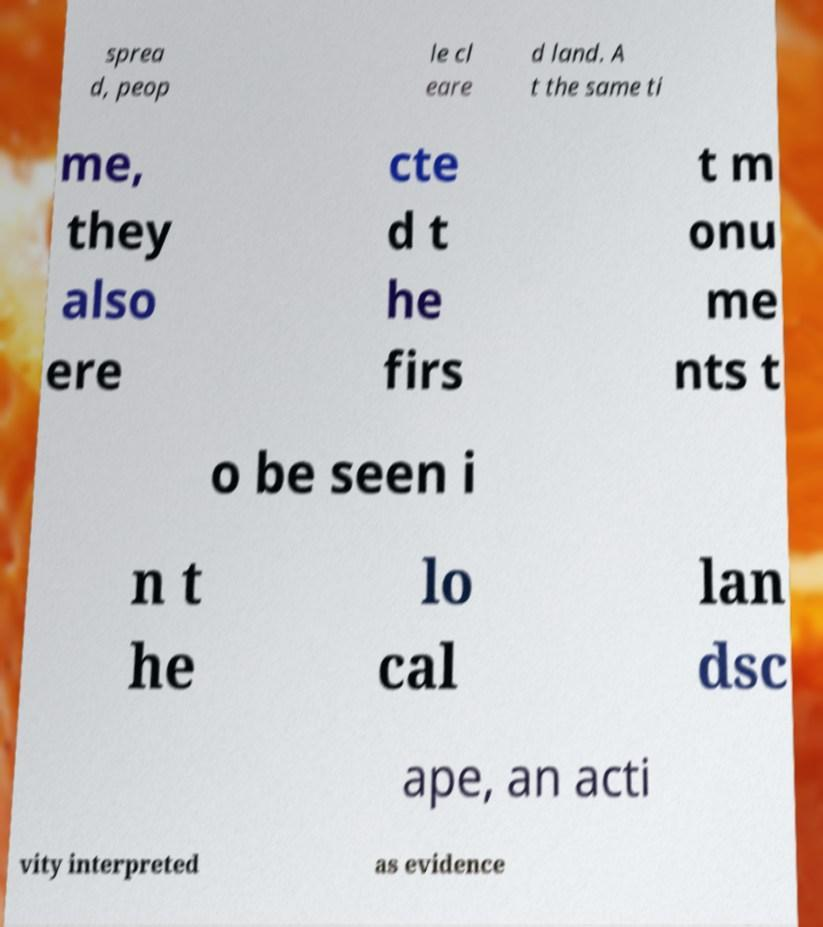Could you extract and type out the text from this image? sprea d, peop le cl eare d land. A t the same ti me, they also ere cte d t he firs t m onu me nts t o be seen i n t he lo cal lan dsc ape, an acti vity interpreted as evidence 